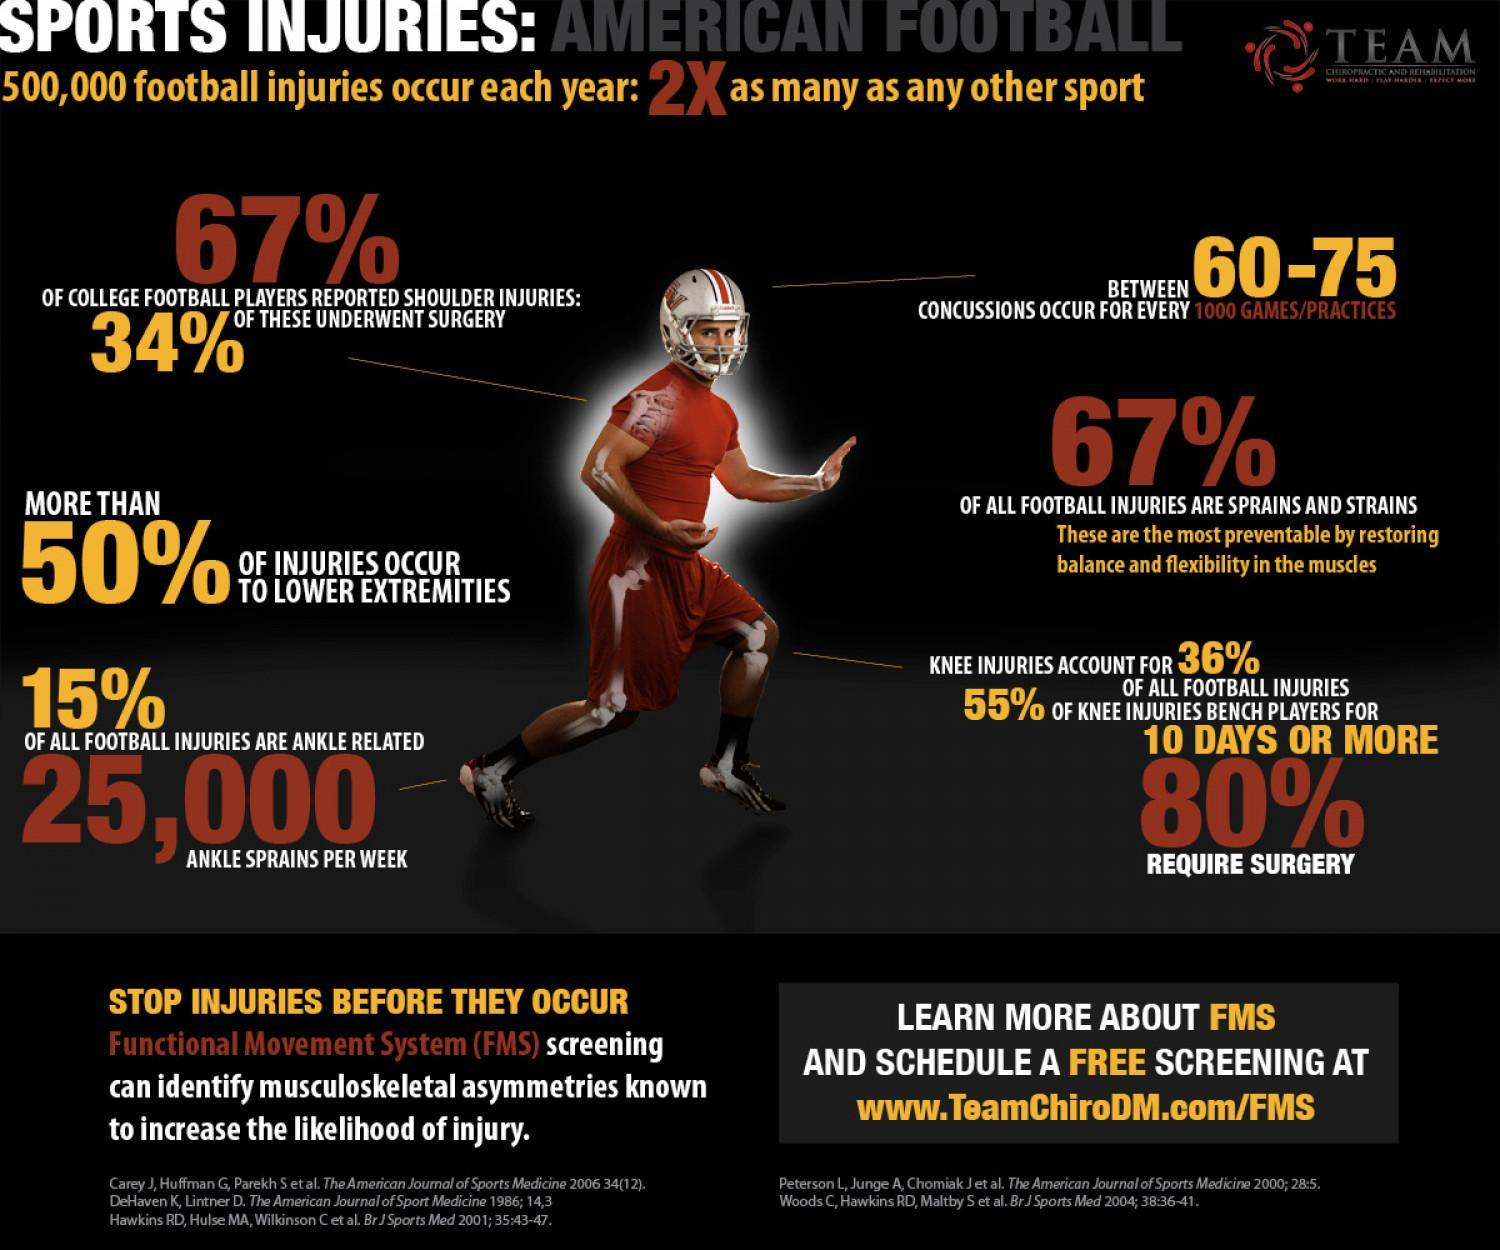Where do majority of injuries happen?
Answer the question with a short phrase. LOWER EXTREMITIES 